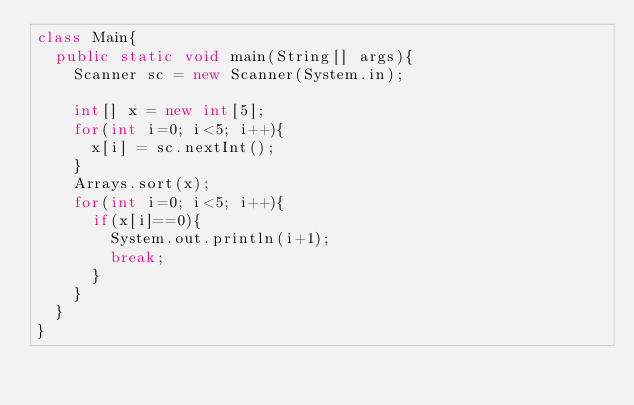Convert code to text. <code><loc_0><loc_0><loc_500><loc_500><_Java_>class Main{
  public static void main(String[] args){
    Scanner sc = new Scanner(System.in);
    
    int[] x = new int[5];
    for(int i=0; i<5; i++){
      x[i] = sc.nextInt();
    }
    Arrays.sort(x);
    for(int i=0; i<5; i++){
      if(x[i]==0){
        System.out.println(i+1);
        break;
      }
    }
  }
}</code> 